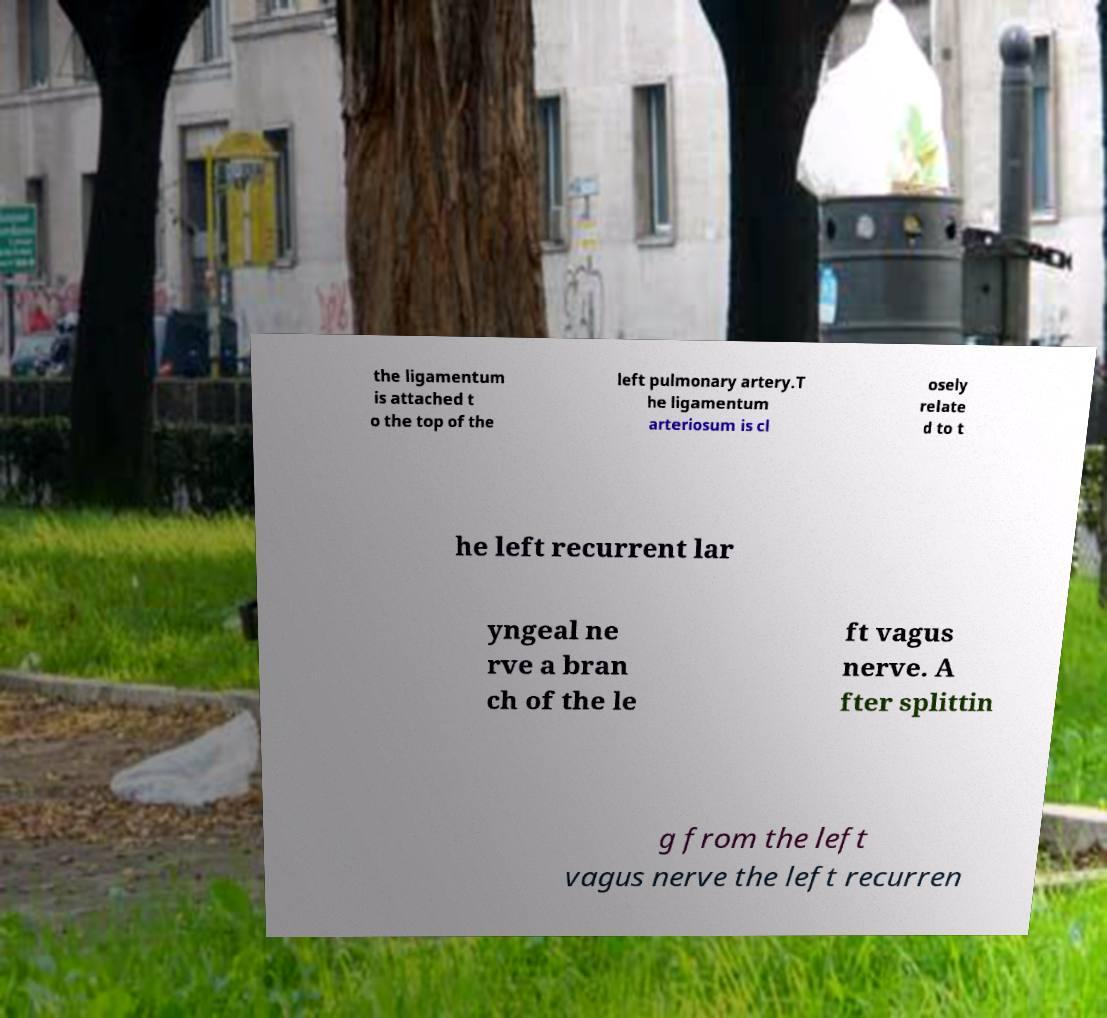I need the written content from this picture converted into text. Can you do that? the ligamentum is attached t o the top of the left pulmonary artery.T he ligamentum arteriosum is cl osely relate d to t he left recurrent lar yngeal ne rve a bran ch of the le ft vagus nerve. A fter splittin g from the left vagus nerve the left recurren 